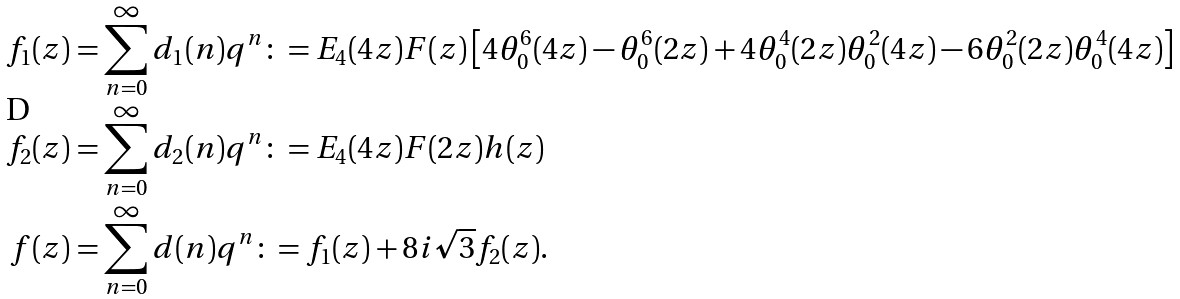<formula> <loc_0><loc_0><loc_500><loc_500>f _ { 1 } ( z ) & = \sum _ { n = 0 } ^ { \infty } d _ { 1 } ( n ) q ^ { n } \colon = E _ { 4 } ( 4 z ) F ( z ) \left [ 4 \theta _ { 0 } ^ { 6 } ( 4 z ) - \theta _ { 0 } ^ { 6 } ( 2 z ) + 4 \theta _ { 0 } ^ { 4 } ( 2 z ) \theta _ { 0 } ^ { 2 } ( 4 z ) - 6 \theta _ { 0 } ^ { 2 } ( 2 z ) \theta _ { 0 } ^ { 4 } ( 4 z ) \right ] \\ f _ { 2 } ( z ) & = \sum _ { n = 0 } ^ { \infty } d _ { 2 } ( n ) q ^ { n } \colon = E _ { 4 } ( 4 z ) F ( 2 z ) h ( z ) \\ f ( z ) & = \sum _ { n = 0 } ^ { \infty } d ( n ) q ^ { n } \colon = f _ { 1 } ( z ) + 8 i \sqrt { 3 } f _ { 2 } ( z ) .</formula> 